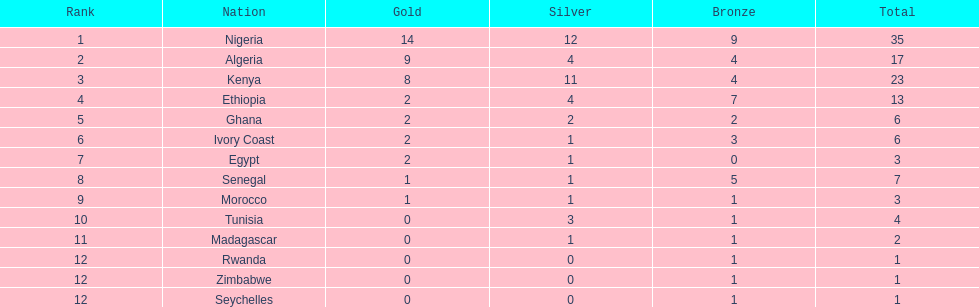How many medals did senegal win? 7. 